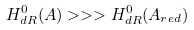<formula> <loc_0><loc_0><loc_500><loc_500>H _ { d R } ^ { 0 } ( A ) > > > H _ { d R } ^ { 0 } ( A _ { r e d } )</formula> 